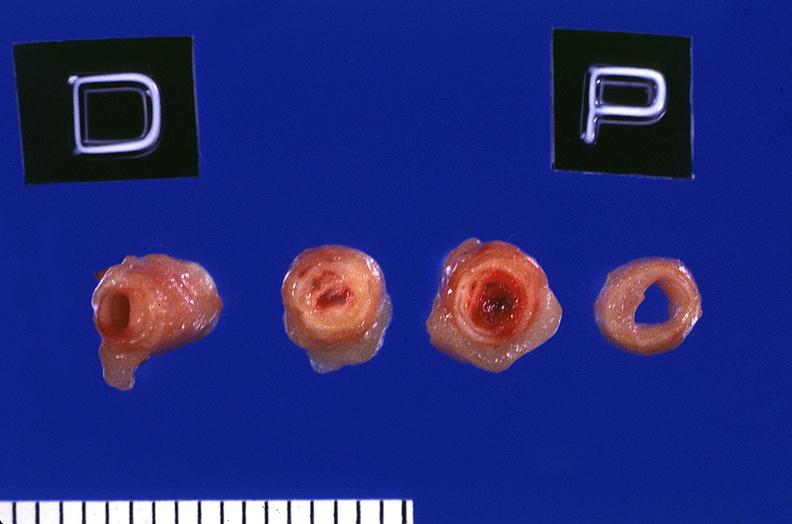how does this image show coronary artery?
Answer the question using a single word or phrase. With atherosclerosis and thrombotic occlusion 